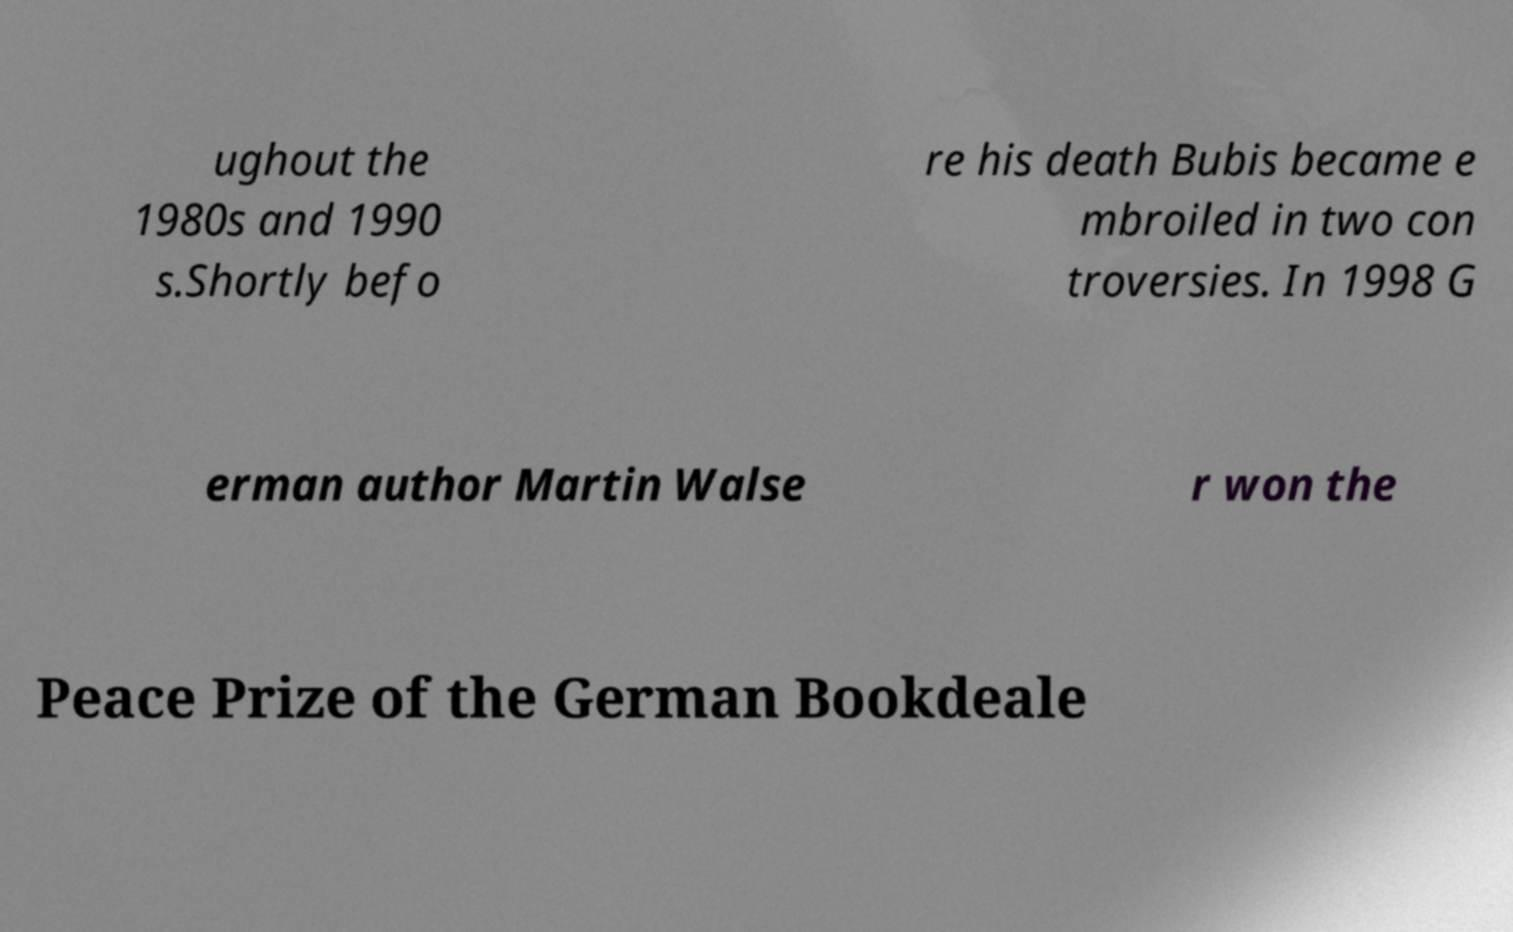Please read and relay the text visible in this image. What does it say? ughout the 1980s and 1990 s.Shortly befo re his death Bubis became e mbroiled in two con troversies. In 1998 G erman author Martin Walse r won the Peace Prize of the German Bookdeale 